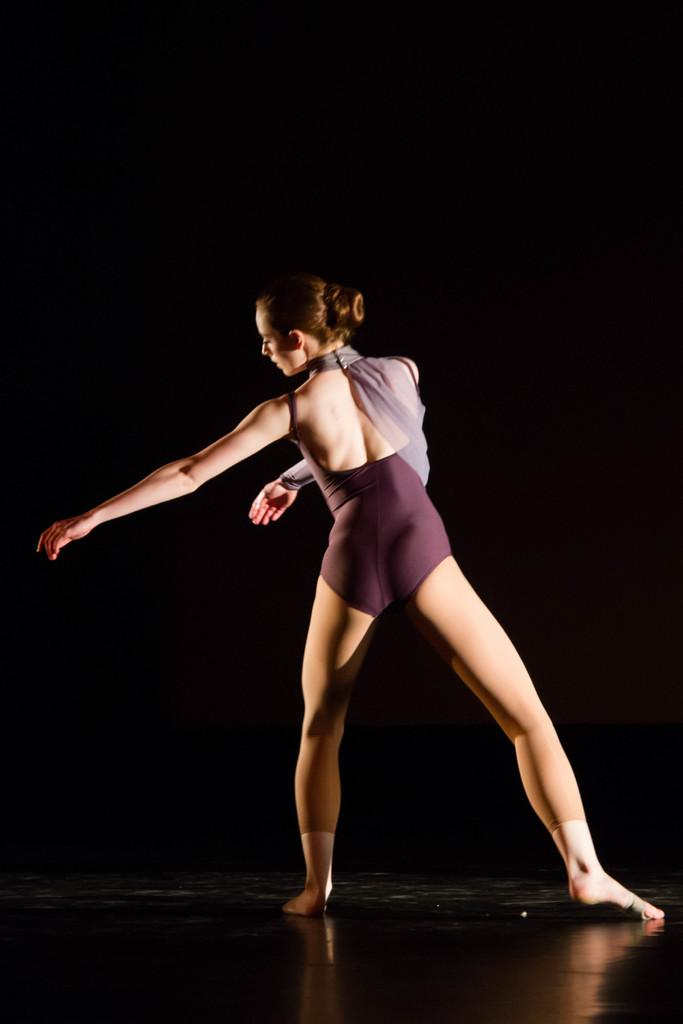What is the main subject of the image? The main subject of the image is a lady person. What is the lady person wearing? The lady person is wearing a bikini. What is the lady person doing in the image? The lady person is dancing on the floor. What educational rule is being enforced in the image? There is no mention of any educational rule in the image; it features a lady person dancing in a bikini. 